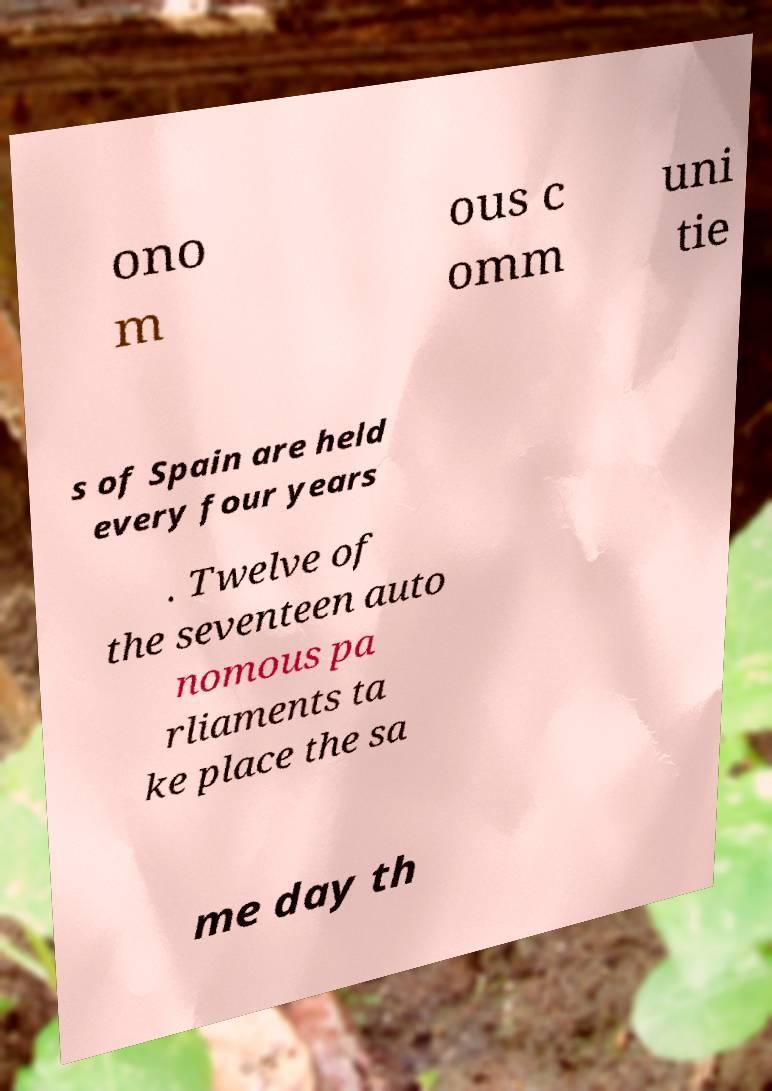Please read and relay the text visible in this image. What does it say? ono m ous c omm uni tie s of Spain are held every four years . Twelve of the seventeen auto nomous pa rliaments ta ke place the sa me day th 